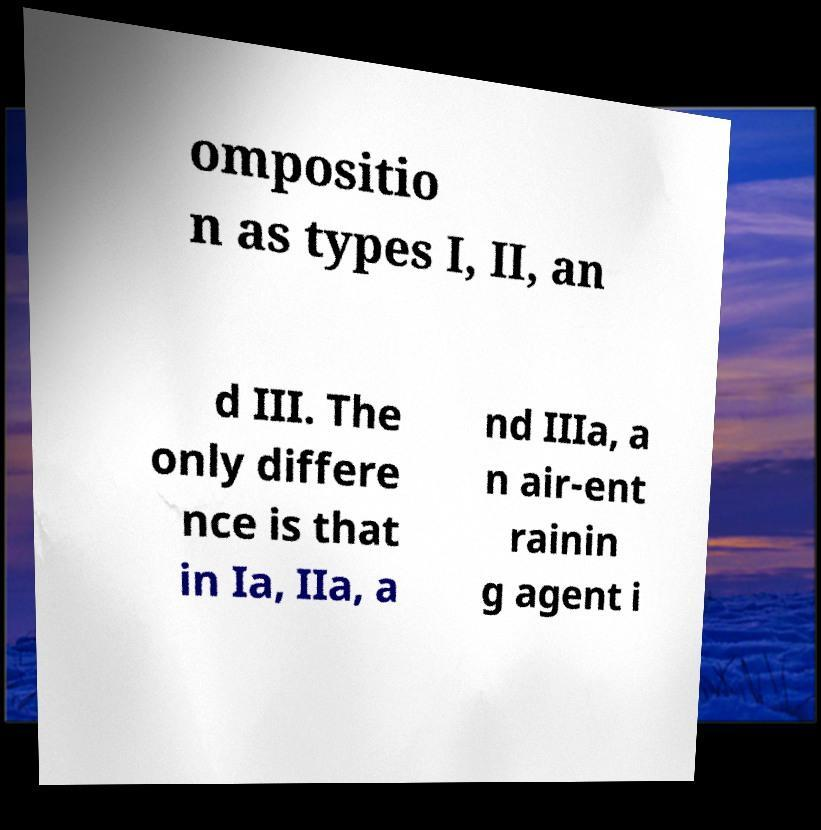I need the written content from this picture converted into text. Can you do that? ompositio n as types I, II, an d III. The only differe nce is that in Ia, IIa, a nd IIIa, a n air-ent rainin g agent i 